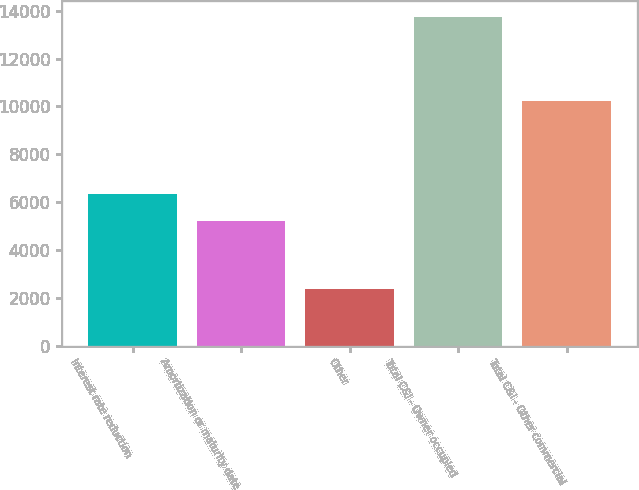Convert chart to OTSL. <chart><loc_0><loc_0><loc_500><loc_500><bar_chart><fcel>Interest rate reduction<fcel>Amortization or maturity date<fcel>Other<fcel>Total C&I - Owner occupied<fcel>Total C&I - Other commercial<nl><fcel>6338.4<fcel>5201<fcel>2352<fcel>13726<fcel>10238<nl></chart> 